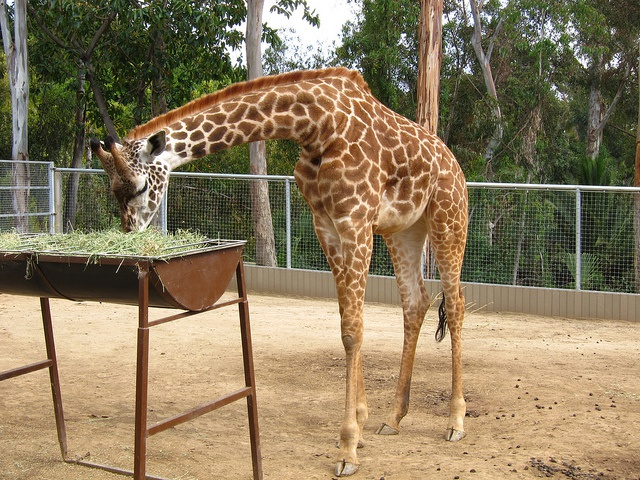Describe the objects in this image and their specific colors. I can see a giraffe in gray, brown, tan, and maroon tones in this image. 